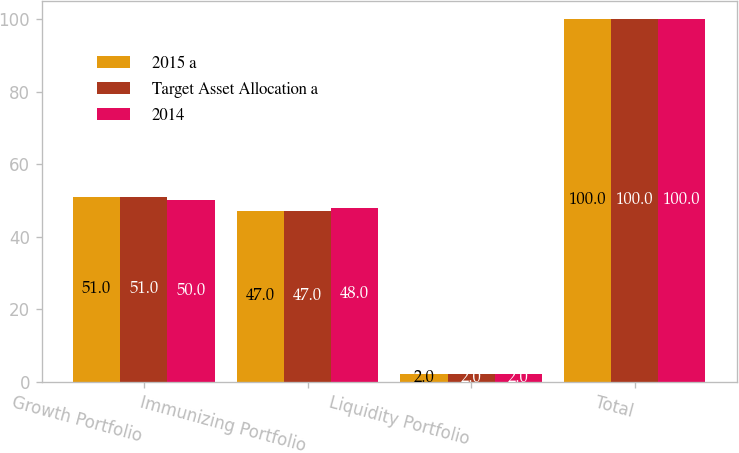<chart> <loc_0><loc_0><loc_500><loc_500><stacked_bar_chart><ecel><fcel>Growth Portfolio<fcel>Immunizing Portfolio<fcel>Liquidity Portfolio<fcel>Total<nl><fcel>2015 a<fcel>51<fcel>47<fcel>2<fcel>100<nl><fcel>Target Asset Allocation a<fcel>51<fcel>47<fcel>2<fcel>100<nl><fcel>2014<fcel>50<fcel>48<fcel>2<fcel>100<nl></chart> 